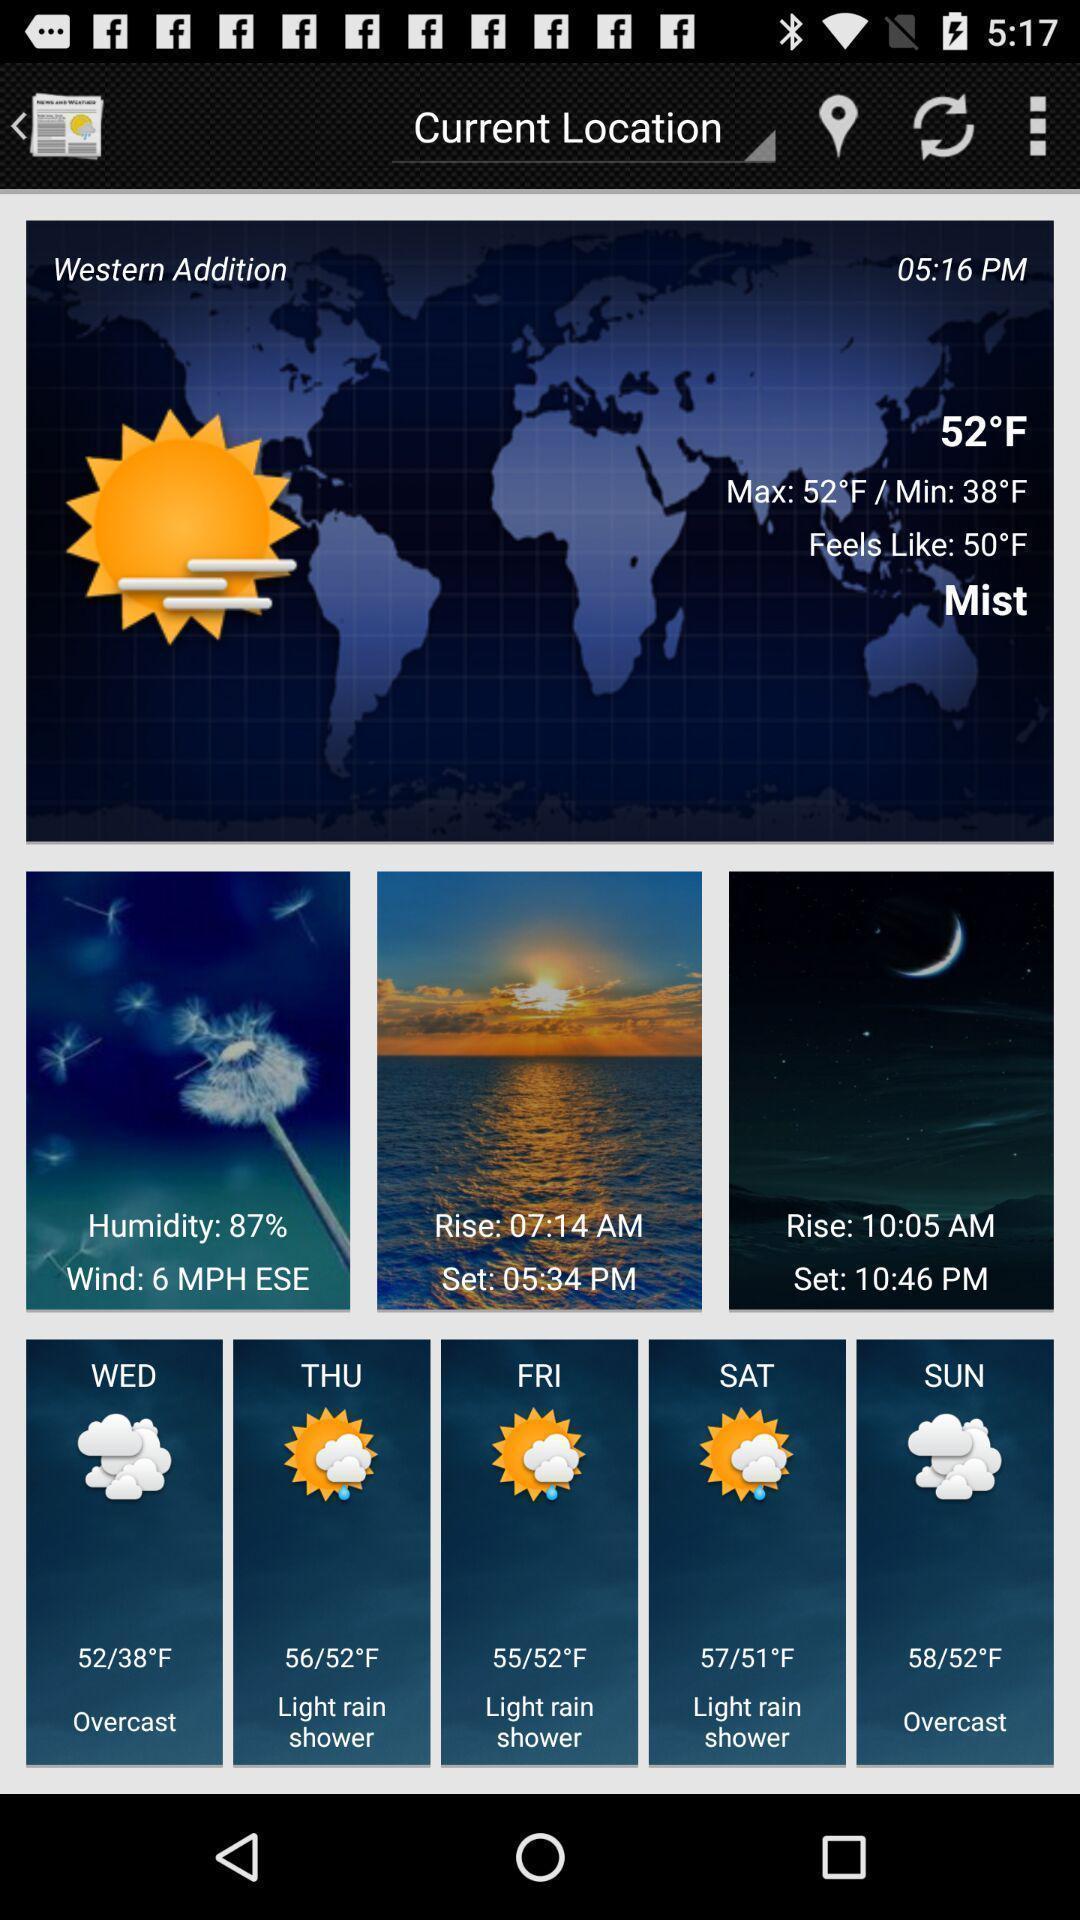What is the overall content of this screenshot? Weather status displaying in this page. 